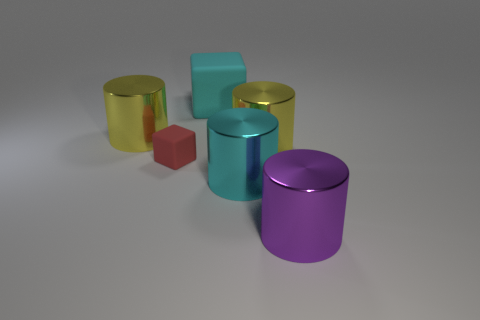There is a big cylinder that is the same color as the big rubber object; what is it made of?
Keep it short and to the point. Metal. Is the number of cyan cylinders greater than the number of large gray metal balls?
Provide a short and direct response. Yes. There is a cube that is the same size as the cyan cylinder; what is it made of?
Your response must be concise. Rubber. Does the big purple cylinder have the same material as the small red object?
Give a very brief answer. No. What number of small purple spheres are the same material as the large cyan cube?
Keep it short and to the point. 0. How many things are matte blocks behind the tiny red thing or cyan things that are on the right side of the large cyan matte thing?
Provide a succinct answer. 2. Is the number of tiny rubber objects to the right of the big rubber cube greater than the number of cyan things that are on the right side of the cyan metallic cylinder?
Offer a terse response. No. There is a block that is left of the large cyan cube; what color is it?
Provide a succinct answer. Red. Are there any cyan objects that have the same shape as the tiny red matte thing?
Make the answer very short. Yes. How many cyan objects are either cylinders or tiny matte cubes?
Your answer should be compact. 1. 